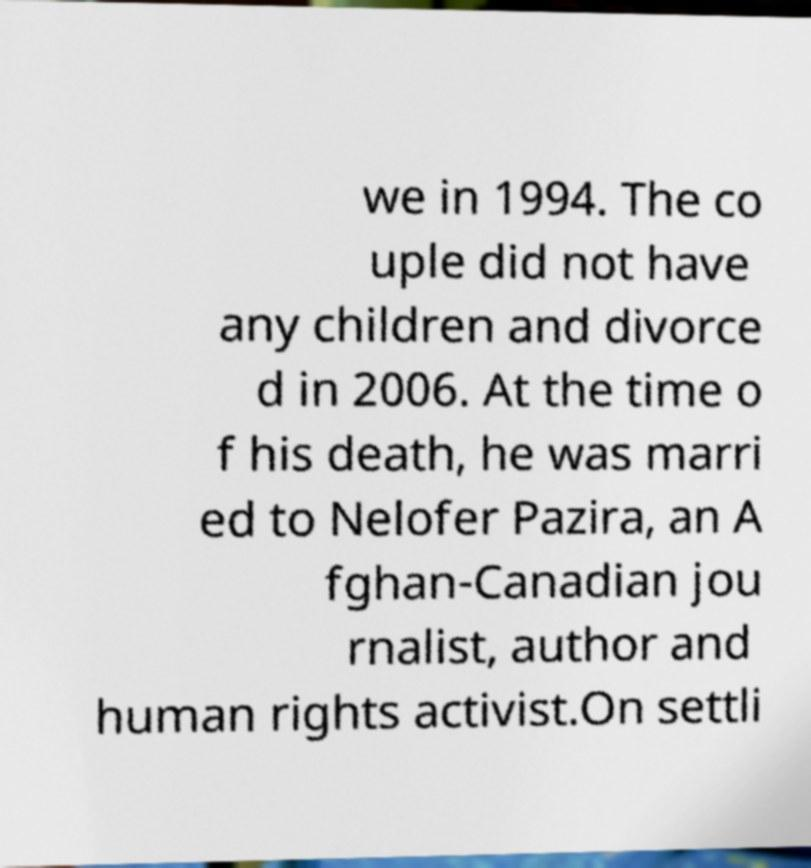I need the written content from this picture converted into text. Can you do that? we in 1994. The co uple did not have any children and divorce d in 2006. At the time o f his death, he was marri ed to Nelofer Pazira, an A fghan-Canadian jou rnalist, author and human rights activist.On settli 